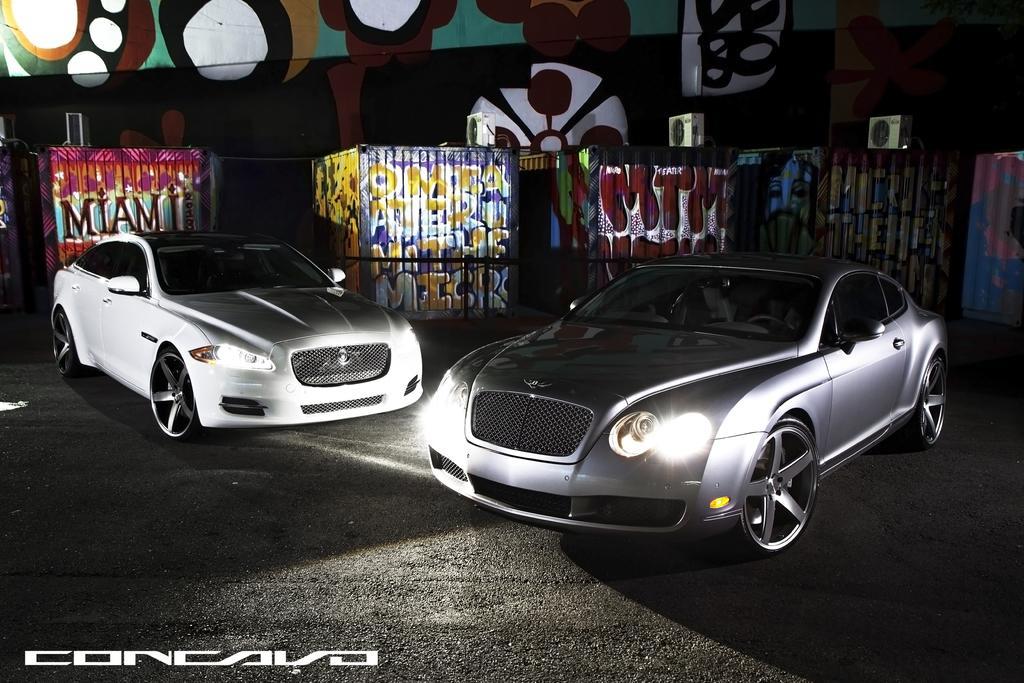In one or two sentences, can you explain what this image depicts? In this image I can see two cars and in the background and see graffiti. Here I can see watermark and I can see this image is little bit in dark. 